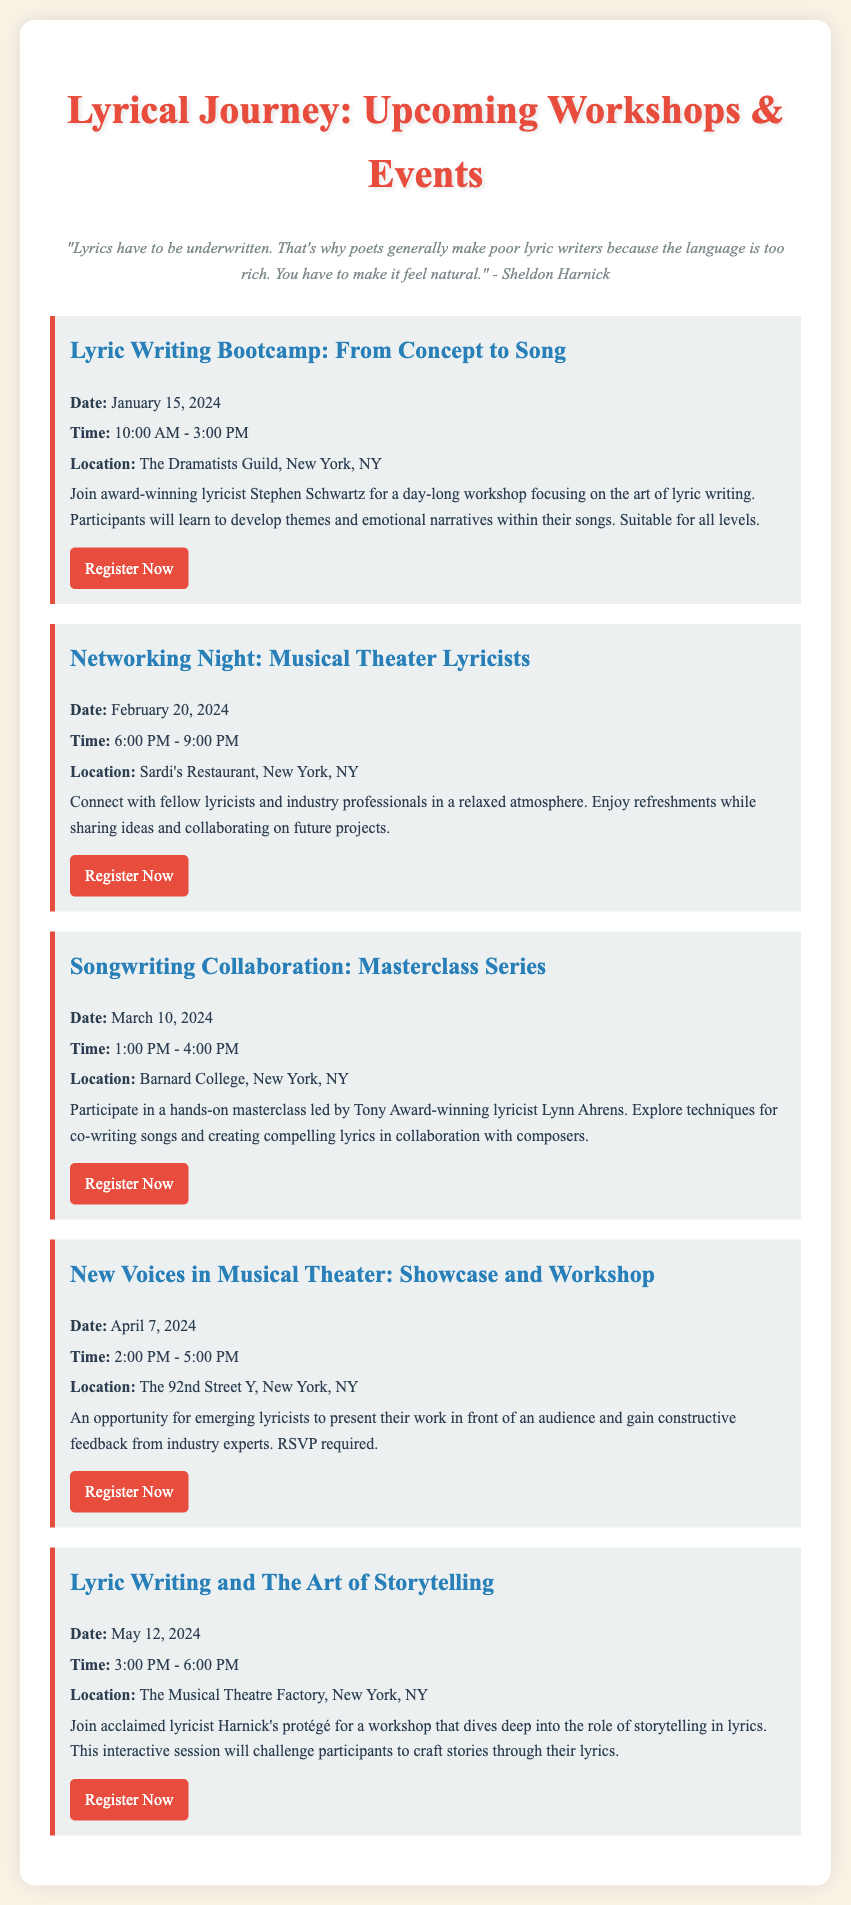what is the date of the Lyric Writing Bootcamp? The date is specified as January 15, 2024.
Answer: January 15, 2024 who is leading the Songwriting Collaboration masterclass? The document mentions that Lynn Ahrens will be leading the masterclass.
Answer: Lynn Ahrens what is the time for the Networking Night event? The time is noted as 6:00 PM to 9:00 PM on February 20, 2024.
Answer: 6:00 PM - 9:00 PM where is the Lyric Writing and The Art of Storytelling workshop located? The document indicates that it will be held at The Musical Theatre Factory in New York, NY.
Answer: The Musical Theatre Factory how many events are listed in total? The document lists a total of five separate events for lyric writing workshops and networking opportunities.
Answer: Five which event provides an opportunity for emerging lyricists to present their work? The New Voices in Musical Theater event is specified for presenting work and receiving feedback.
Answer: New Voices in Musical Theater what type of atmosphere is the Networking Night described as? The description describes the atmosphere as relaxed for connecting with fellow lyricists.
Answer: Relaxed when is the deadline for RSVPing for the New Voices in Musical Theater event? The document states that RSVP is required, but does not specify a deadline.
Answer: Not specified 